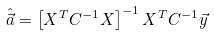<formula> <loc_0><loc_0><loc_500><loc_500>\hat { \vec { a } } = \left [ X ^ { T } C ^ { - 1 } X \right ] ^ { - 1 } X ^ { T } C ^ { - 1 } \vec { y }</formula> 